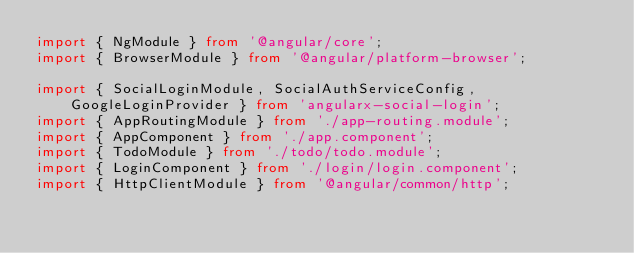<code> <loc_0><loc_0><loc_500><loc_500><_TypeScript_>import { NgModule } from '@angular/core';
import { BrowserModule } from '@angular/platform-browser';

import { SocialLoginModule, SocialAuthServiceConfig, GoogleLoginProvider } from 'angularx-social-login';
import { AppRoutingModule } from './app-routing.module';
import { AppComponent } from './app.component';
import { TodoModule } from './todo/todo.module';
import { LoginComponent } from './login/login.component';
import { HttpClientModule } from '@angular/common/http';</code> 